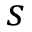Convert formula to latex. <formula><loc_0><loc_0><loc_500><loc_500>s</formula> 